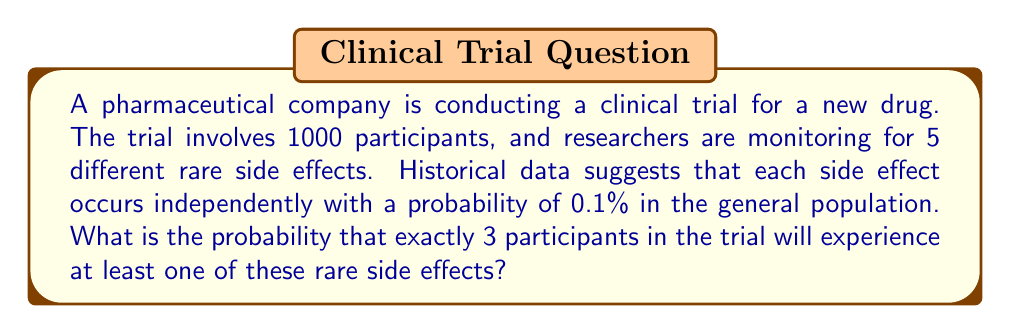Teach me how to tackle this problem. To solve this problem, we'll use combinatorial analysis and the binomial probability formula. Let's break it down step-by-step:

1) First, we need to calculate the probability of a single participant experiencing at least one of the rare side effects.

   Let $p$ be the probability of experiencing at least one side effect.
   $p = 1 - $ (probability of experiencing no side effects)
   $p = 1 - (0.999)^5 = 1 - 0.995004995 \approx 0.004995005$

2) Now, we can treat this as a binomial probability problem. We want the probability of exactly 3 successes (participants with at least one side effect) out of 1000 trials.

3) The binomial probability formula is:

   $P(X = k) = \binom{n}{k} p^k (1-p)^{n-k}$

   Where:
   $n$ = number of trials (1000)
   $k$ = number of successes (3)
   $p$ = probability of success on a single trial (0.004995005)

4) Substituting these values:

   $P(X = 3) = \binom{1000}{3} (0.004995005)^3 (1-0.004995005)^{1000-3}$

5) Calculate:
   
   $\binom{1000}{3} = \frac{1000!}{3!(1000-3)!} = 166167000$
   
   $(0.004995005)^3 \approx 1.24625 \times 10^{-7}$
   
   $(1-0.004995005)^{997} \approx 0.993761$

6) Multiply these values:

   $166167000 \times 1.24625 \times 10^{-7} \times 0.993761 \approx 0.0205$

Therefore, the probability is approximately 0.0205 or 2.05%.
Answer: The probability that exactly 3 participants in the trial will experience at least one of the rare side effects is approximately 0.0205 or 2.05%. 